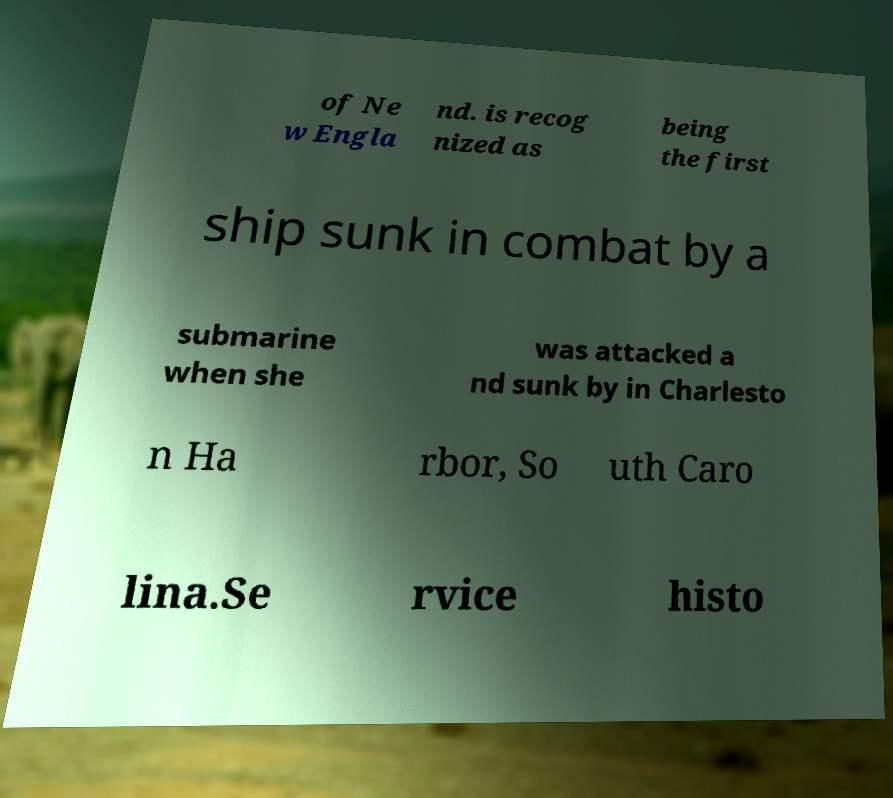For documentation purposes, I need the text within this image transcribed. Could you provide that? of Ne w Engla nd. is recog nized as being the first ship sunk in combat by a submarine when she was attacked a nd sunk by in Charlesto n Ha rbor, So uth Caro lina.Se rvice histo 